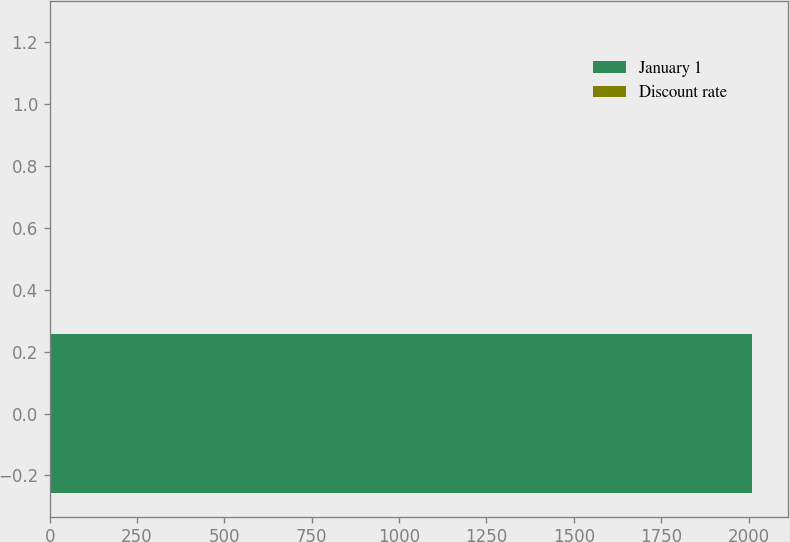Convert chart to OTSL. <chart><loc_0><loc_0><loc_500><loc_500><bar_chart><fcel>January 1<fcel>Discount rate<nl><fcel>2011<fcel>4.65<nl></chart> 